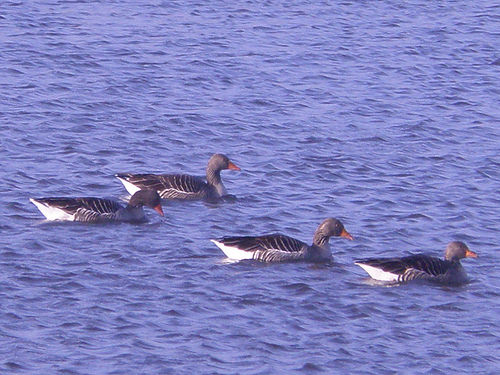<image>
Can you confirm if the water is on the duck? No. The water is not positioned on the duck. They may be near each other, but the water is not supported by or resting on top of the duck. Is the duck next to the duck? No. The duck is not positioned next to the duck. They are located in different areas of the scene. Is there a duck above the sea? No. The duck is not positioned above the sea. The vertical arrangement shows a different relationship. 